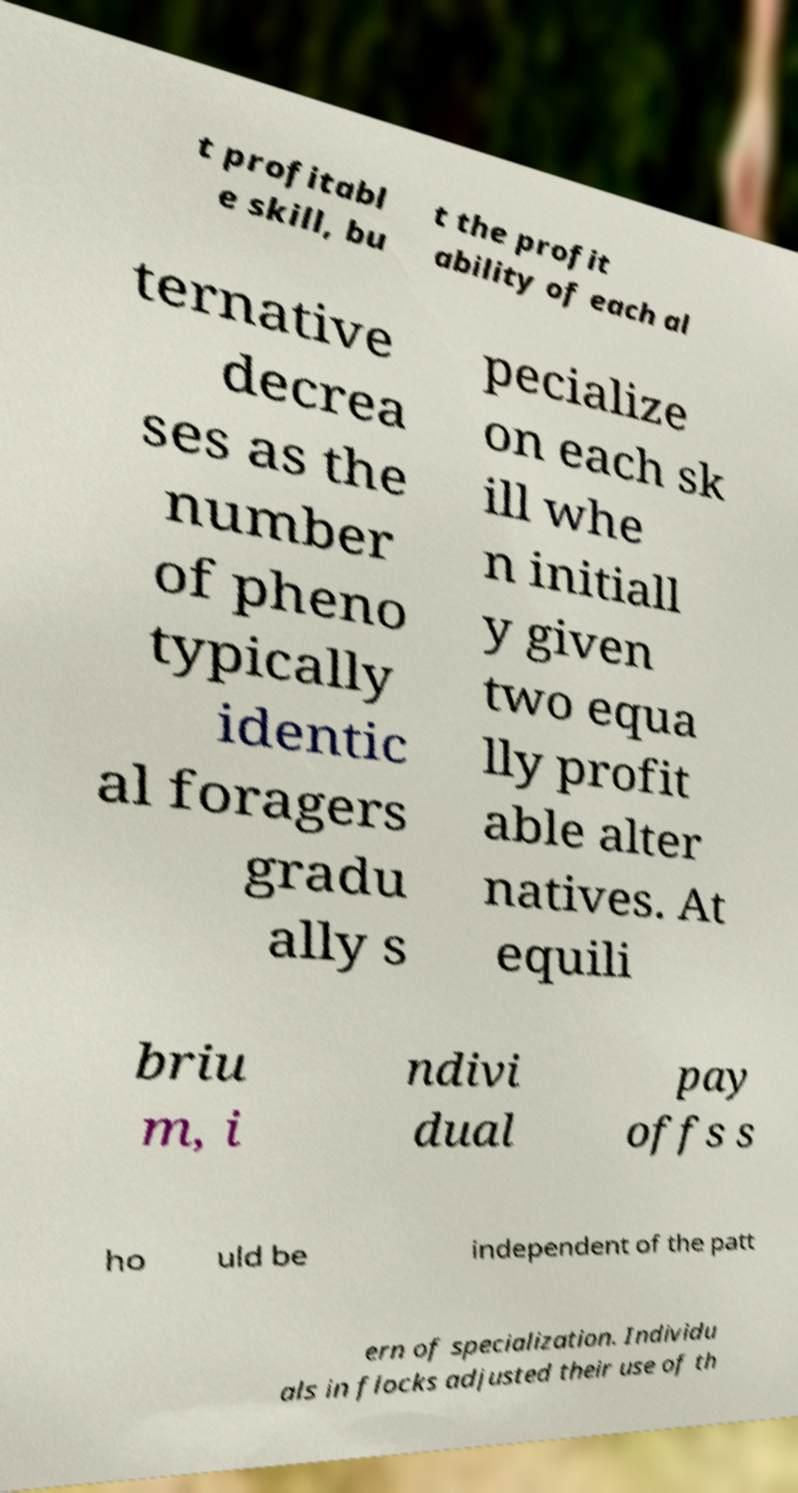Can you read and provide the text displayed in the image?This photo seems to have some interesting text. Can you extract and type it out for me? t profitabl e skill, bu t the profit ability of each al ternative decrea ses as the number of pheno typically identic al foragers gradu ally s pecialize on each sk ill whe n initiall y given two equa lly profit able alter natives. At equili briu m, i ndivi dual pay offs s ho uld be independent of the patt ern of specialization. Individu als in flocks adjusted their use of th 